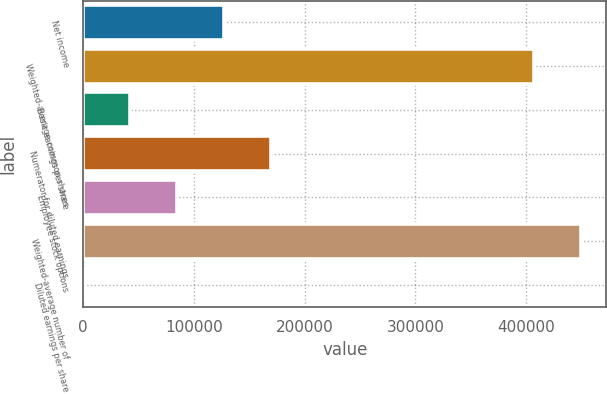Convert chart. <chart><loc_0><loc_0><loc_500><loc_500><bar_chart><fcel>Net income<fcel>Weighted-average common shares<fcel>Basic earnings per share<fcel>Numerator for diluted earnings<fcel>Employee stock options<fcel>Weighted-average number of<fcel>Diluted earnings per share<nl><fcel>127598<fcel>407385<fcel>42532.9<fcel>170131<fcel>85065.6<fcel>449918<fcel>0.26<nl></chart> 